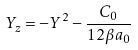<formula> <loc_0><loc_0><loc_500><loc_500>Y _ { z } = - Y ^ { 2 } - \frac { C _ { 0 } } { 1 2 \beta a _ { 0 } }</formula> 